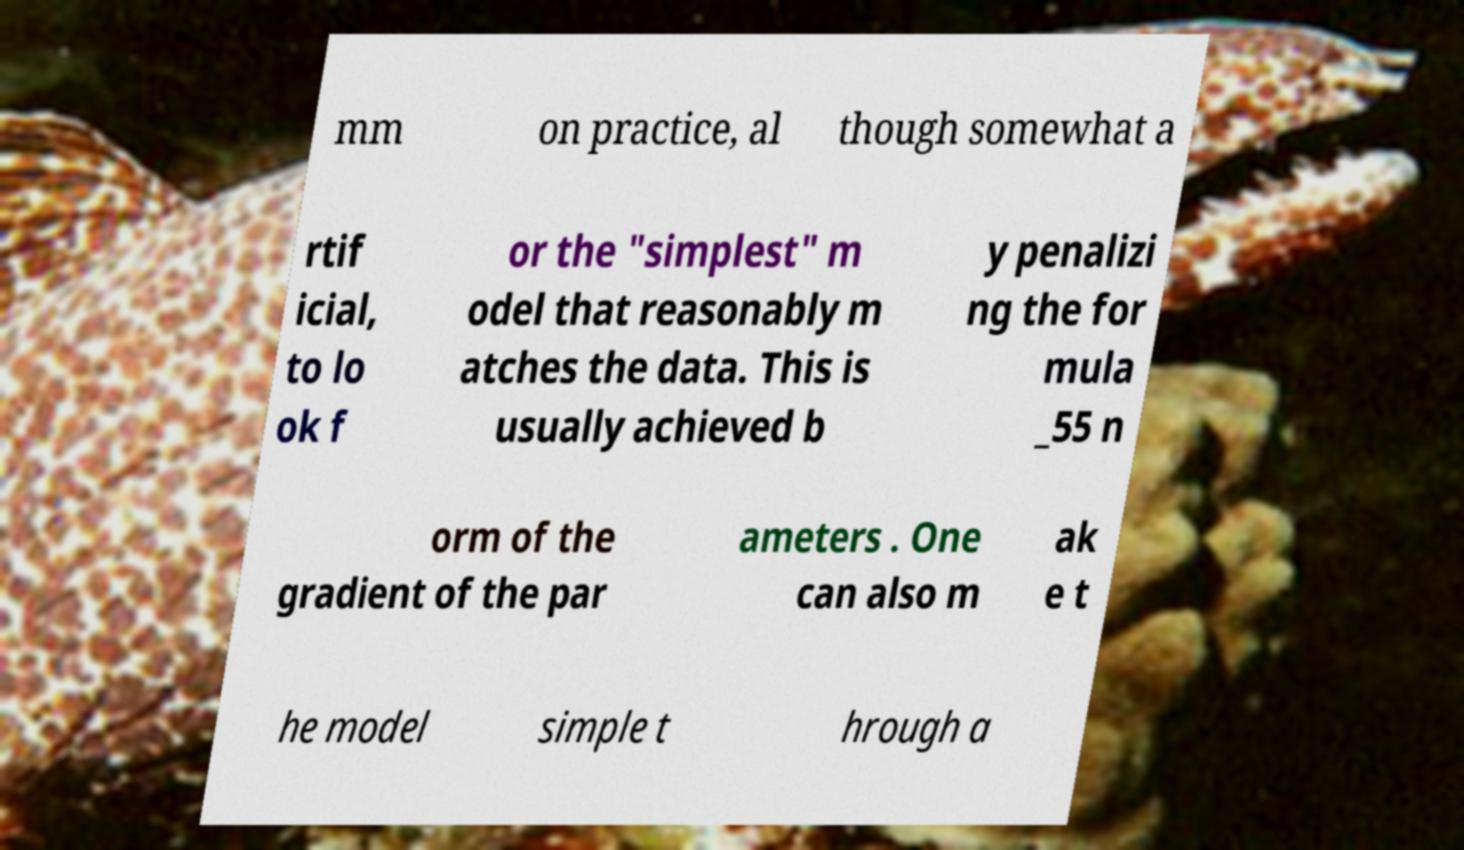What messages or text are displayed in this image? I need them in a readable, typed format. mm on practice, al though somewhat a rtif icial, to lo ok f or the "simplest" m odel that reasonably m atches the data. This is usually achieved b y penalizi ng the for mula _55 n orm of the gradient of the par ameters . One can also m ak e t he model simple t hrough a 